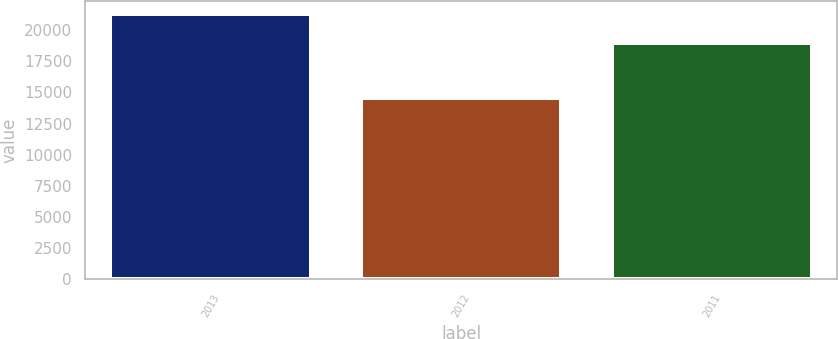Convert chart. <chart><loc_0><loc_0><loc_500><loc_500><bar_chart><fcel>2013<fcel>2012<fcel>2011<nl><fcel>21259<fcel>14554<fcel>18950<nl></chart> 